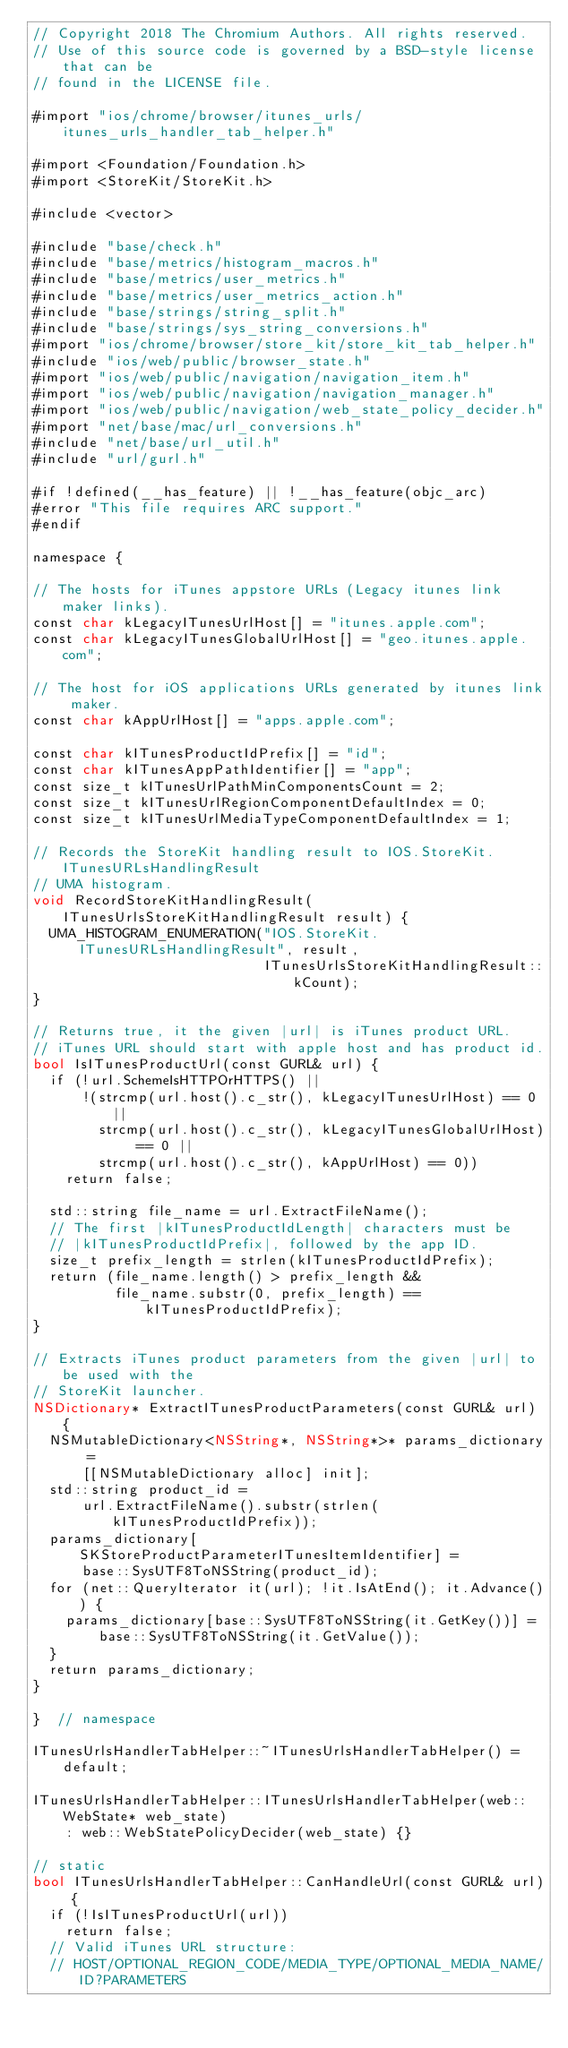<code> <loc_0><loc_0><loc_500><loc_500><_ObjectiveC_>// Copyright 2018 The Chromium Authors. All rights reserved.
// Use of this source code is governed by a BSD-style license that can be
// found in the LICENSE file.

#import "ios/chrome/browser/itunes_urls/itunes_urls_handler_tab_helper.h"

#import <Foundation/Foundation.h>
#import <StoreKit/StoreKit.h>

#include <vector>

#include "base/check.h"
#include "base/metrics/histogram_macros.h"
#include "base/metrics/user_metrics.h"
#include "base/metrics/user_metrics_action.h"
#include "base/strings/string_split.h"
#include "base/strings/sys_string_conversions.h"
#import "ios/chrome/browser/store_kit/store_kit_tab_helper.h"
#include "ios/web/public/browser_state.h"
#import "ios/web/public/navigation/navigation_item.h"
#import "ios/web/public/navigation/navigation_manager.h"
#import "ios/web/public/navigation/web_state_policy_decider.h"
#import "net/base/mac/url_conversions.h"
#include "net/base/url_util.h"
#include "url/gurl.h"

#if !defined(__has_feature) || !__has_feature(objc_arc)
#error "This file requires ARC support."
#endif

namespace {

// The hosts for iTunes appstore URLs (Legacy itunes link maker links).
const char kLegacyITunesUrlHost[] = "itunes.apple.com";
const char kLegacyITunesGlobalUrlHost[] = "geo.itunes.apple.com";

// The host for iOS applications URLs generated by itunes link maker.
const char kAppUrlHost[] = "apps.apple.com";

const char kITunesProductIdPrefix[] = "id";
const char kITunesAppPathIdentifier[] = "app";
const size_t kITunesUrlPathMinComponentsCount = 2;
const size_t kITunesUrlRegionComponentDefaultIndex = 0;
const size_t kITunesUrlMediaTypeComponentDefaultIndex = 1;

// Records the StoreKit handling result to IOS.StoreKit.ITunesURLsHandlingResult
// UMA histogram.
void RecordStoreKitHandlingResult(ITunesUrlsStoreKitHandlingResult result) {
  UMA_HISTOGRAM_ENUMERATION("IOS.StoreKit.ITunesURLsHandlingResult", result,
                            ITunesUrlsStoreKitHandlingResult::kCount);
}

// Returns true, it the given |url| is iTunes product URL.
// iTunes URL should start with apple host and has product id.
bool IsITunesProductUrl(const GURL& url) {
  if (!url.SchemeIsHTTPOrHTTPS() ||
      !(strcmp(url.host().c_str(), kLegacyITunesUrlHost) == 0 ||
        strcmp(url.host().c_str(), kLegacyITunesGlobalUrlHost) == 0 ||
        strcmp(url.host().c_str(), kAppUrlHost) == 0))
    return false;

  std::string file_name = url.ExtractFileName();
  // The first |kITunesProductIdLength| characters must be
  // |kITunesProductIdPrefix|, followed by the app ID.
  size_t prefix_length = strlen(kITunesProductIdPrefix);
  return (file_name.length() > prefix_length &&
          file_name.substr(0, prefix_length) == kITunesProductIdPrefix);
}

// Extracts iTunes product parameters from the given |url| to be used with the
// StoreKit launcher.
NSDictionary* ExtractITunesProductParameters(const GURL& url) {
  NSMutableDictionary<NSString*, NSString*>* params_dictionary =
      [[NSMutableDictionary alloc] init];
  std::string product_id =
      url.ExtractFileName().substr(strlen(kITunesProductIdPrefix));
  params_dictionary[SKStoreProductParameterITunesItemIdentifier] =
      base::SysUTF8ToNSString(product_id);
  for (net::QueryIterator it(url); !it.IsAtEnd(); it.Advance()) {
    params_dictionary[base::SysUTF8ToNSString(it.GetKey())] =
        base::SysUTF8ToNSString(it.GetValue());
  }
  return params_dictionary;
}

}  // namespace

ITunesUrlsHandlerTabHelper::~ITunesUrlsHandlerTabHelper() = default;

ITunesUrlsHandlerTabHelper::ITunesUrlsHandlerTabHelper(web::WebState* web_state)
    : web::WebStatePolicyDecider(web_state) {}

// static
bool ITunesUrlsHandlerTabHelper::CanHandleUrl(const GURL& url) {
  if (!IsITunesProductUrl(url))
    return false;
  // Valid iTunes URL structure:
  // HOST/OPTIONAL_REGION_CODE/MEDIA_TYPE/OPTIONAL_MEDIA_NAME/ID?PARAMETERS</code> 